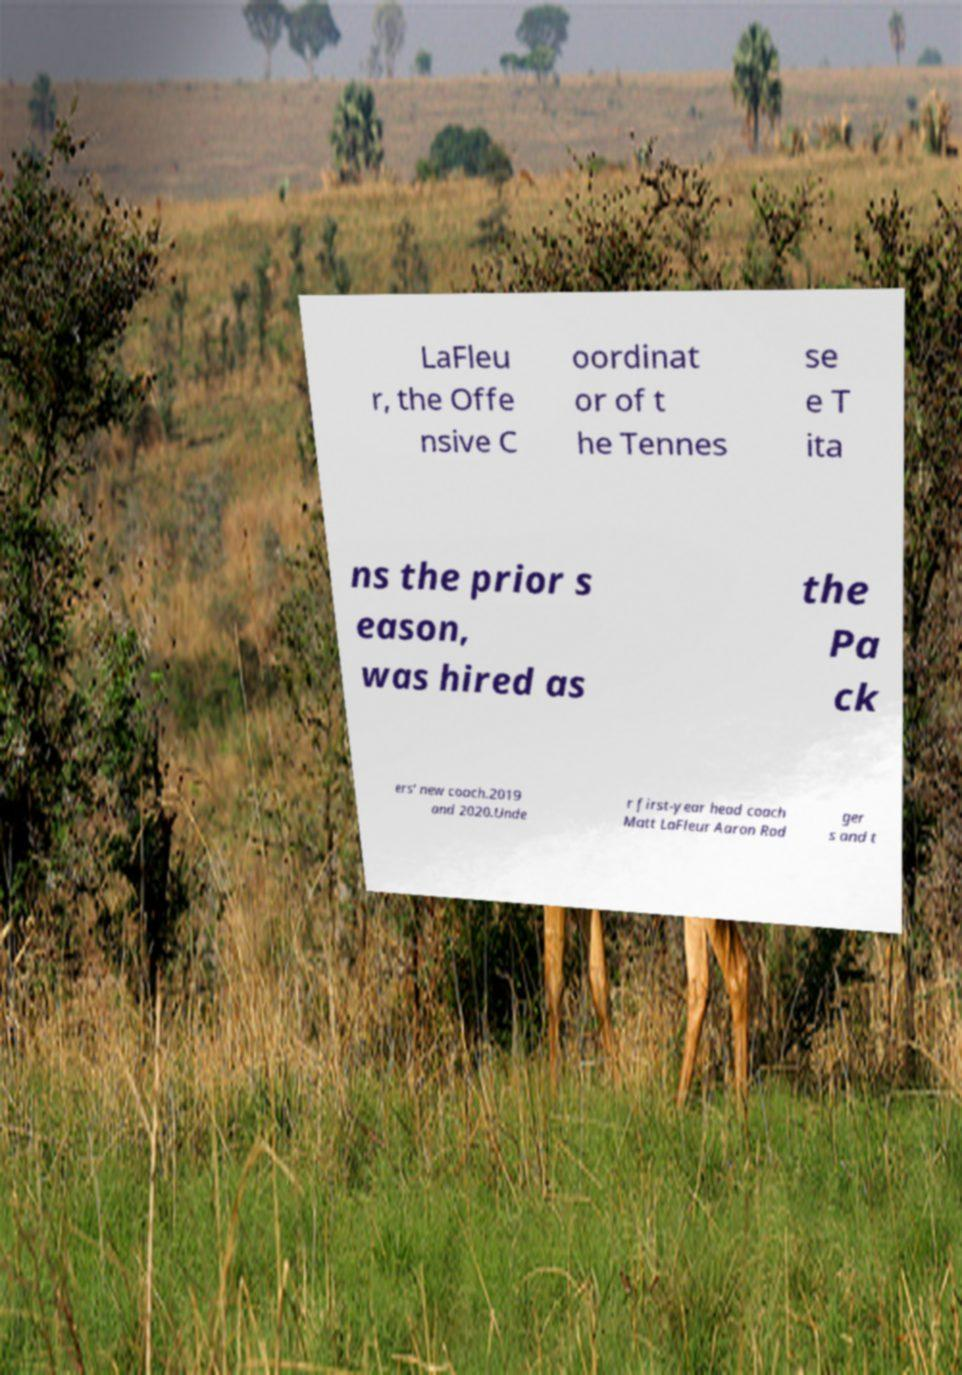There's text embedded in this image that I need extracted. Can you transcribe it verbatim? LaFleu r, the Offe nsive C oordinat or of t he Tennes se e T ita ns the prior s eason, was hired as the Pa ck ers' new coach.2019 and 2020.Unde r first-year head coach Matt LaFleur Aaron Rod ger s and t 